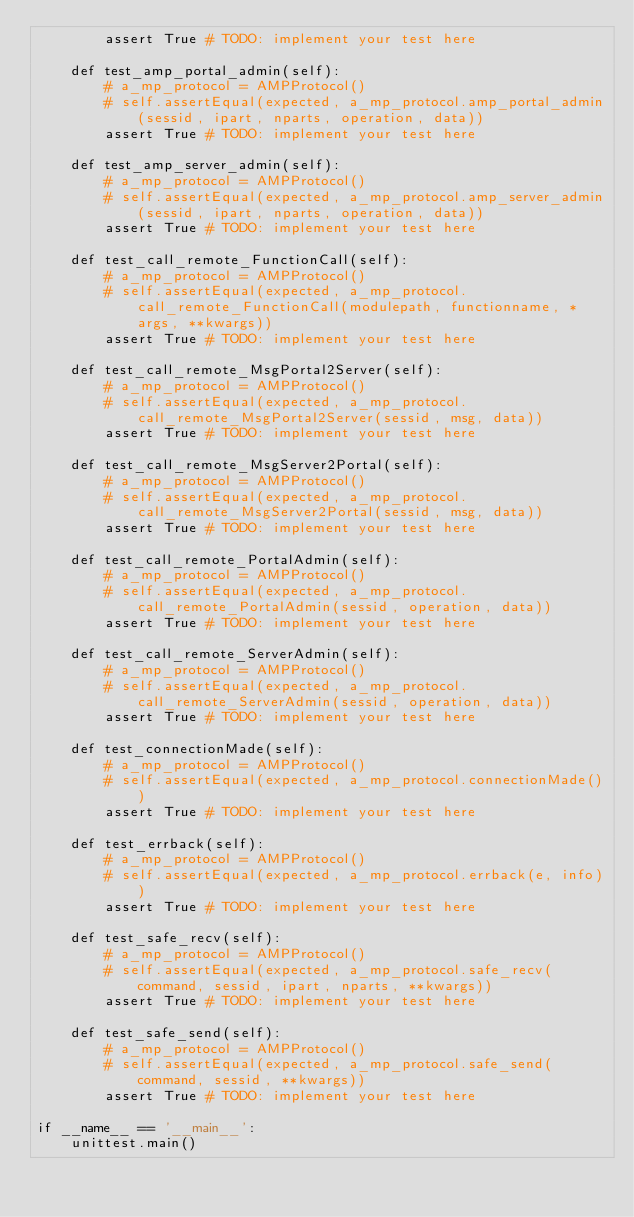Convert code to text. <code><loc_0><loc_0><loc_500><loc_500><_Python_>        assert True # TODO: implement your test here

    def test_amp_portal_admin(self):
        # a_mp_protocol = AMPProtocol()
        # self.assertEqual(expected, a_mp_protocol.amp_portal_admin(sessid, ipart, nparts, operation, data))
        assert True # TODO: implement your test here

    def test_amp_server_admin(self):
        # a_mp_protocol = AMPProtocol()
        # self.assertEqual(expected, a_mp_protocol.amp_server_admin(sessid, ipart, nparts, operation, data))
        assert True # TODO: implement your test here

    def test_call_remote_FunctionCall(self):
        # a_mp_protocol = AMPProtocol()
        # self.assertEqual(expected, a_mp_protocol.call_remote_FunctionCall(modulepath, functionname, *args, **kwargs))
        assert True # TODO: implement your test here

    def test_call_remote_MsgPortal2Server(self):
        # a_mp_protocol = AMPProtocol()
        # self.assertEqual(expected, a_mp_protocol.call_remote_MsgPortal2Server(sessid, msg, data))
        assert True # TODO: implement your test here

    def test_call_remote_MsgServer2Portal(self):
        # a_mp_protocol = AMPProtocol()
        # self.assertEqual(expected, a_mp_protocol.call_remote_MsgServer2Portal(sessid, msg, data))
        assert True # TODO: implement your test here

    def test_call_remote_PortalAdmin(self):
        # a_mp_protocol = AMPProtocol()
        # self.assertEqual(expected, a_mp_protocol.call_remote_PortalAdmin(sessid, operation, data))
        assert True # TODO: implement your test here

    def test_call_remote_ServerAdmin(self):
        # a_mp_protocol = AMPProtocol()
        # self.assertEqual(expected, a_mp_protocol.call_remote_ServerAdmin(sessid, operation, data))
        assert True # TODO: implement your test here

    def test_connectionMade(self):
        # a_mp_protocol = AMPProtocol()
        # self.assertEqual(expected, a_mp_protocol.connectionMade())
        assert True # TODO: implement your test here

    def test_errback(self):
        # a_mp_protocol = AMPProtocol()
        # self.assertEqual(expected, a_mp_protocol.errback(e, info))
        assert True # TODO: implement your test here

    def test_safe_recv(self):
        # a_mp_protocol = AMPProtocol()
        # self.assertEqual(expected, a_mp_protocol.safe_recv(command, sessid, ipart, nparts, **kwargs))
        assert True # TODO: implement your test here

    def test_safe_send(self):
        # a_mp_protocol = AMPProtocol()
        # self.assertEqual(expected, a_mp_protocol.safe_send(command, sessid, **kwargs))
        assert True # TODO: implement your test here

if __name__ == '__main__':
    unittest.main()
</code> 